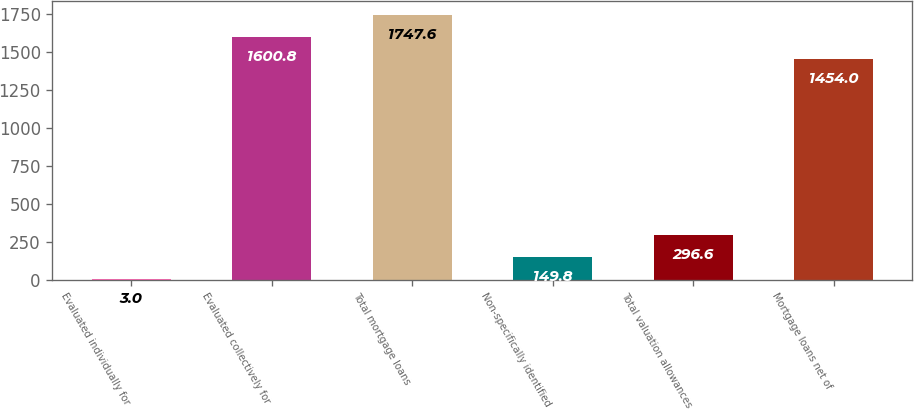Convert chart. <chart><loc_0><loc_0><loc_500><loc_500><bar_chart><fcel>Evaluated individually for<fcel>Evaluated collectively for<fcel>Total mortgage loans<fcel>Non-specifically identified<fcel>Total valuation allowances<fcel>Mortgage loans net of<nl><fcel>3<fcel>1600.8<fcel>1747.6<fcel>149.8<fcel>296.6<fcel>1454<nl></chart> 